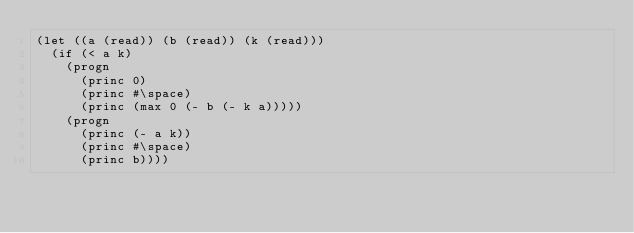Convert code to text. <code><loc_0><loc_0><loc_500><loc_500><_Lisp_>(let ((a (read)) (b (read)) (k (read)))
  (if (< a k)
	(progn
	  (princ 0)
	  (princ #\space)
	  (princ (max 0 (- b (- k a)))))
	(progn
	  (princ (- a k))
	  (princ #\space)
	  (princ b))))
</code> 